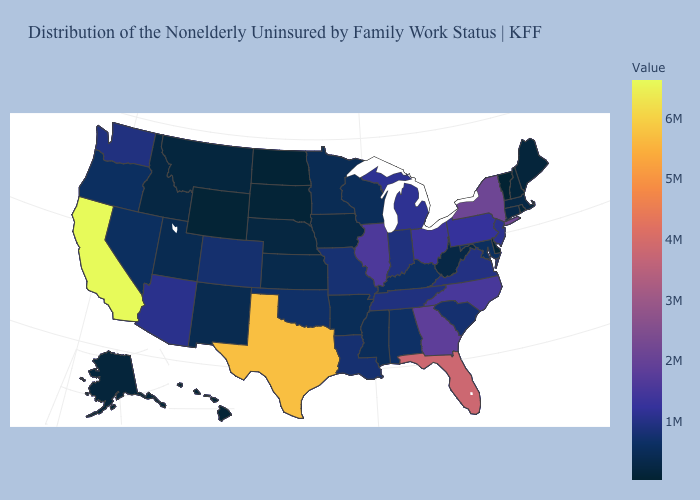Is the legend a continuous bar?
Give a very brief answer. Yes. Among the states that border New Mexico , which have the highest value?
Concise answer only. Texas. Does Texas have the highest value in the South?
Short answer required. Yes. 